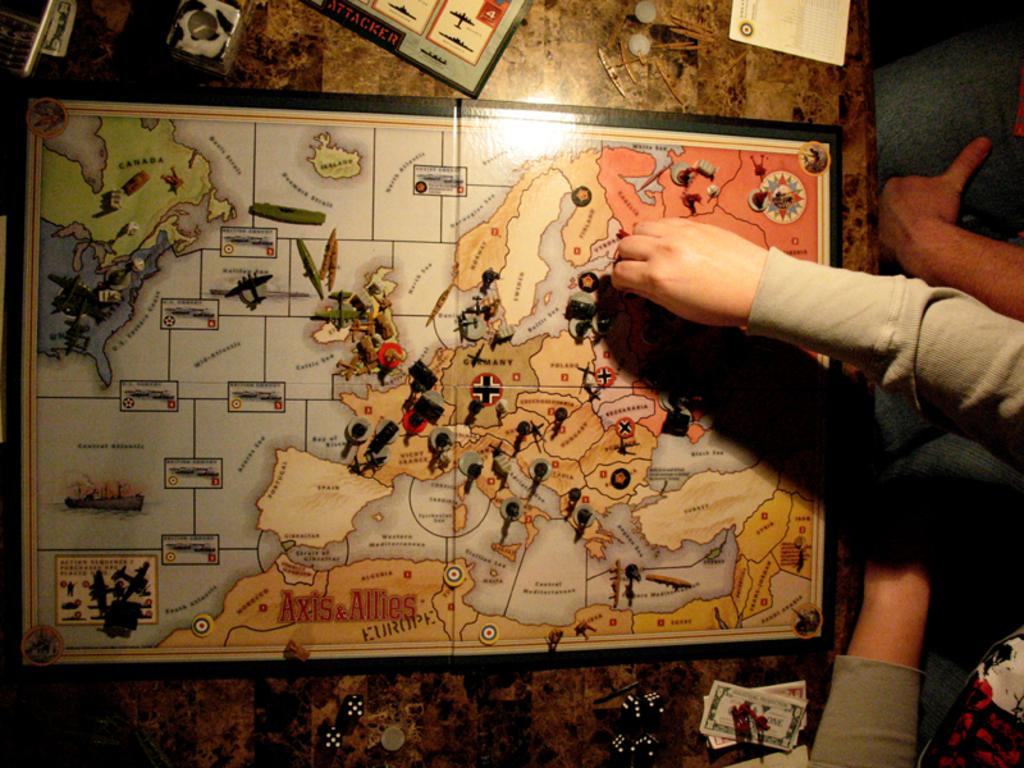What is the main subject of the image? The main subject of the image is a frame of a map. What are the people in the image doing? Two people are sitting and watching the map. What can be seen at the bottom of the image? There are pieces placed at the bottom of the image. What type of creature is flying with a wing in the image? There is no creature or wing present in the image; it features a frame of a map and people watching it. What kind of produce is being harvested in the image? There is no produce or harvesting activity depicted in the image. 